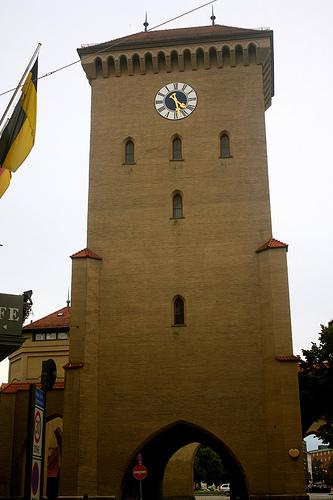Question: who is in the picture?
Choices:
A. A man.
B. A woman.
C. No one.
D. Children.
Answer with the letter. Answer: C Question: what color is the flag?
Choices:
A. White.
B. Red and White.
C. Red and green.
D. Yellow and green.
Answer with the letter. Answer: D Question: where is the photographer?
Choices:
A. On the lawn.
B. In the bedroom.
C. Behind the camera.
D. In a garage.
Answer with the letter. Answer: C 